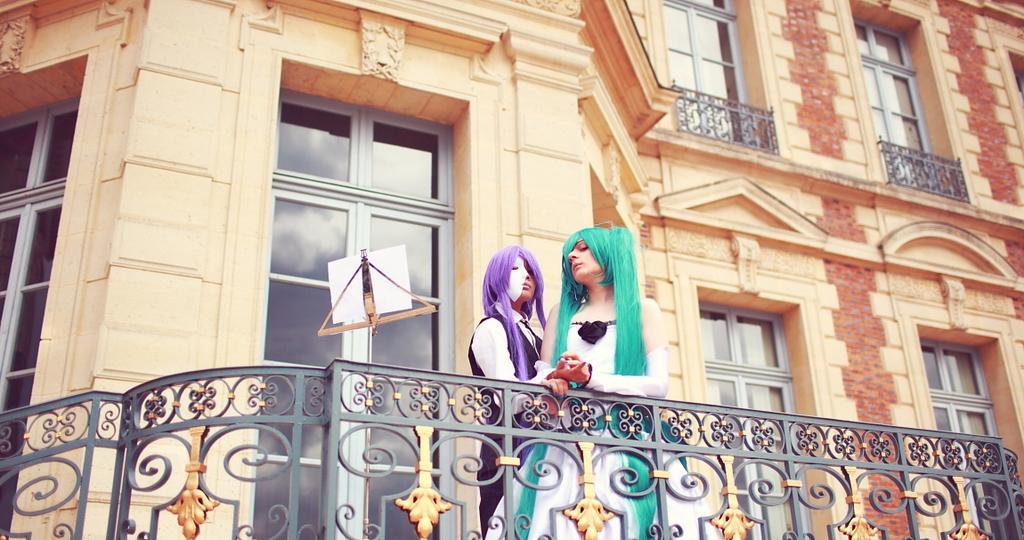Could you give a brief overview of what you see in this image? In this picture we can see two women are standing, in the background there is a building, we can see windows and glasses of this building, at the bottom there is railing, we can see a paper stand in the middle. 